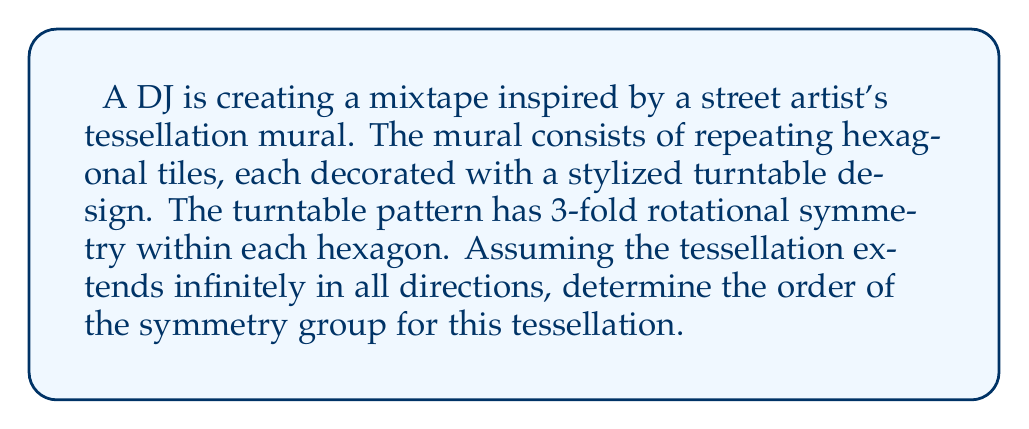Can you answer this question? To analyze the symmetry group of this tessellation, we need to consider both the symmetries of the individual hexagonal tiles and the symmetries of the overall tessellation pattern. Let's break this down step-by-step:

1) Symmetries of individual tiles:
   - Each hexagonal tile has 6-fold rotational symmetry (rotations by multiples of 60°).
   - The turntable design within each hexagon has 3-fold rotational symmetry.
   - The overall symmetry of each tile is the intersection of these, which is 3-fold rotational symmetry.

2) Symmetries of the hexagonal tessellation:
   - Translations: The tessellation has infinite translational symmetry in two independent directions.
   - Rotations: There are centers of 2-fold, 3-fold, and 6-fold rotation.
   - Reflections: There are reflection lines along the edges of the hexagons and through their centers.

3) The symmetry group of this tessellation is a wallpaper group. Based on the symmetries described, this tessellation belongs to the p6 wallpaper group.

4) The order of a wallpaper group is infinite due to the infinite translations. However, we can consider the quotient group obtained by factoring out the translation subgroup.

5) For the p6 group, this quotient group is isomorphic to the dihedral group $D_6$, which has order 12.

6) The fundamental domain of this tessellation is $\frac{1}{12}$ of a hexagonal tile.

Therefore, while the full symmetry group has infinite order, we can characterize it by saying it has 12 distinct symmetry operations modulo translations.
Answer: The symmetry group of the tessellation has infinite order, but its quotient group modulo translations has order 12. 